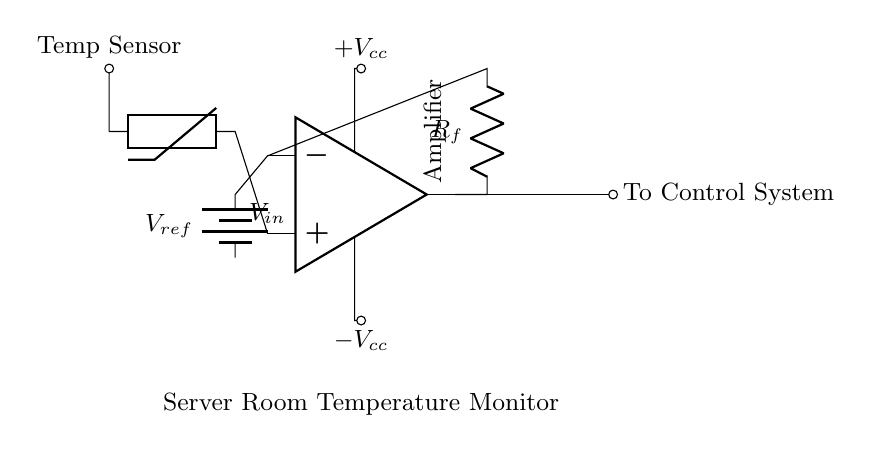What is the type of temperature sensor used in the circuit? The circuit diagram shows a thermistor as the temperature sensor, indicated in the labeled components.
Answer: thermistor What component is used to provide a reference voltage? The circuit uses a battery labeled as V reference to provide the reference voltage to the operational amplifier's inverting terminal.
Answer: battery What is the role of the feedback resistor in this circuit? The feedback resistor, labeled R_f, is connected from the output of the operational amplifier back to its inverting input, which helps control the gain of the amplifier and stabilize the circuit.
Answer: to control gain What power supply voltages are used in this circuit? The diagram indicates +Vcc and -Vcc as the power supply voltages for the operational amplifier, connected to its power input pins.
Answer: +Vcc and -Vcc What is the output of the operational amplifier connected to? The output of the operational amplifier is connected to a control system, as noted in the labels of the output wiring.
Answer: control system How does the thermistor affect the amplifier's input voltage? The thermistor changes resistance according to temperature, which affects the voltage input at the non-inverting terminal of the op-amp, thereby influencing the output based on temperature variations.
Answer: by varying input voltage What would happen if R_f were increased? Increasing R_f would increase the overall gain of the operational amplifier circuit, meaning the output voltage would change more dramatically for a given change in input voltage, allowing for tighter regulation of the temperature reading.
Answer: increased gain 